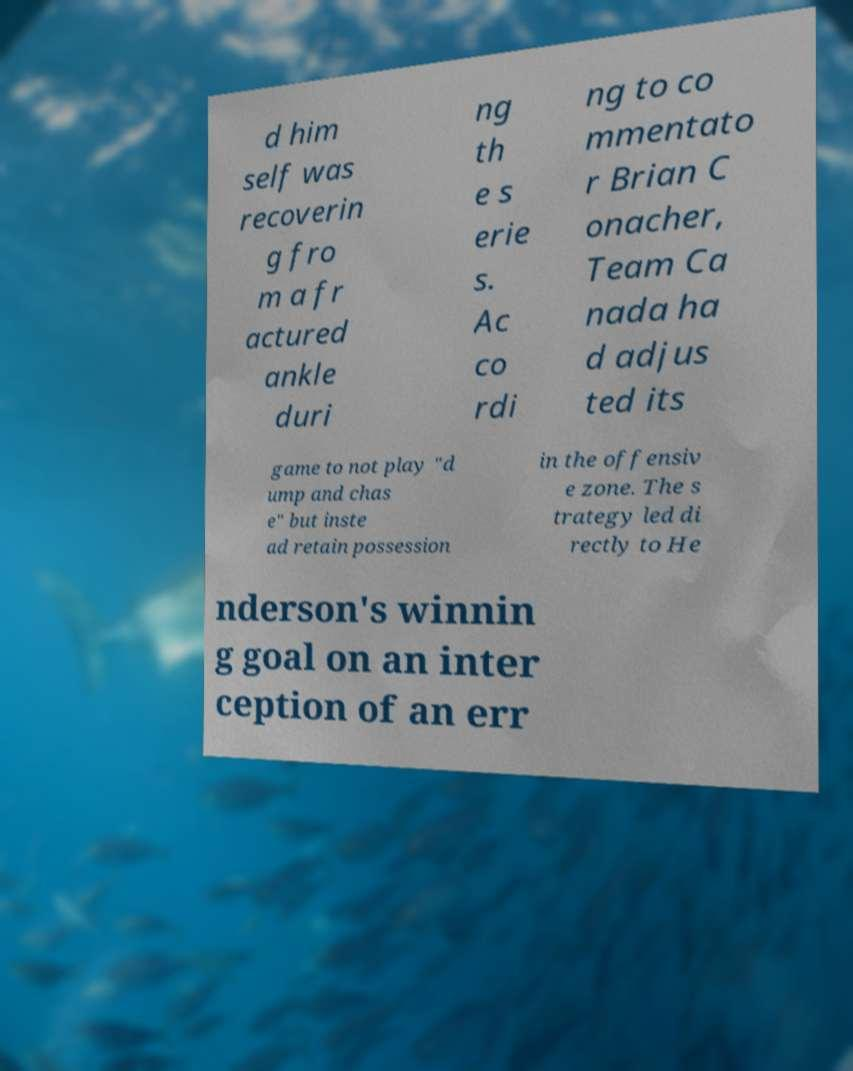Could you assist in decoding the text presented in this image and type it out clearly? d him self was recoverin g fro m a fr actured ankle duri ng th e s erie s. Ac co rdi ng to co mmentato r Brian C onacher, Team Ca nada ha d adjus ted its game to not play "d ump and chas e" but inste ad retain possession in the offensiv e zone. The s trategy led di rectly to He nderson's winnin g goal on an inter ception of an err 